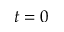Convert formula to latex. <formula><loc_0><loc_0><loc_500><loc_500>t = 0</formula> 